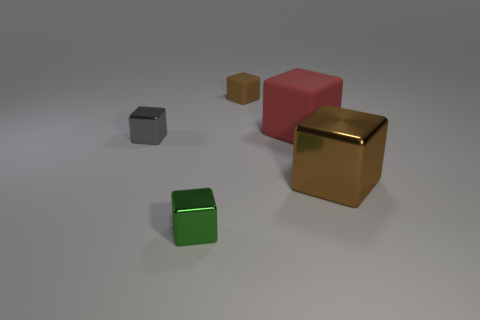Subtract all brown matte blocks. How many blocks are left? 4 Subtract all green blocks. How many blocks are left? 4 Subtract all yellow cubes. Subtract all yellow spheres. How many cubes are left? 5 Add 3 metallic cubes. How many objects exist? 8 Add 5 big brown objects. How many big brown objects are left? 6 Add 5 big cyan metal things. How many big cyan metal things exist? 5 Subtract 0 green cylinders. How many objects are left? 5 Subtract all brown matte blocks. Subtract all brown metallic objects. How many objects are left? 3 